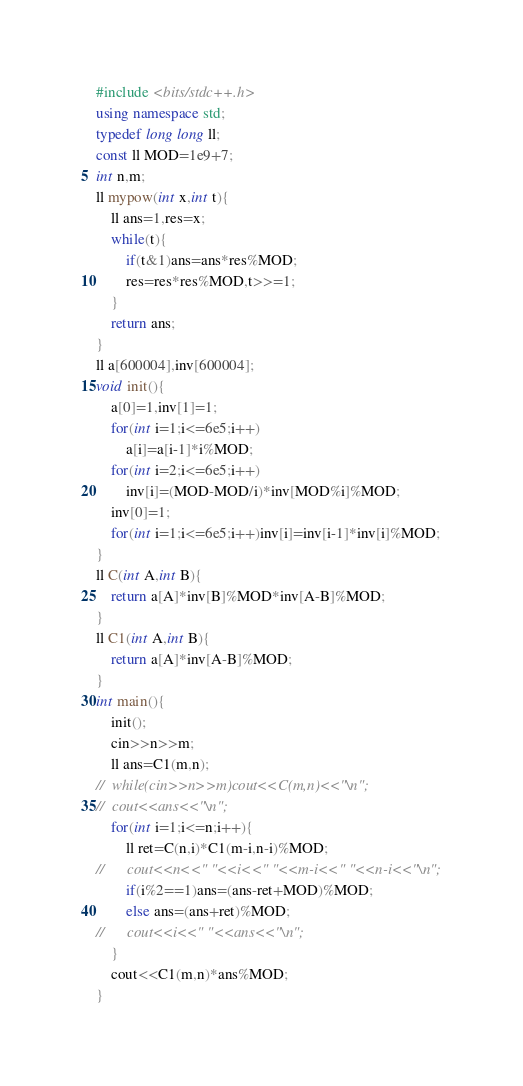Convert code to text. <code><loc_0><loc_0><loc_500><loc_500><_C++_>#include <bits/stdc++.h>
using namespace std;
typedef long long ll;
const ll MOD=1e9+7;
int n,m;
ll mypow(int x,int t){
	ll ans=1,res=x;
	while(t){
		if(t&1)ans=ans*res%MOD;
		res=res*res%MOD,t>>=1;
	}
	return ans;
}
ll a[600004],inv[600004];
void init(){
	a[0]=1,inv[1]=1;
	for(int i=1;i<=6e5;i++)
		a[i]=a[i-1]*i%MOD;
	for(int i=2;i<=6e5;i++)
		inv[i]=(MOD-MOD/i)*inv[MOD%i]%MOD;
	inv[0]=1;
	for(int i=1;i<=6e5;i++)inv[i]=inv[i-1]*inv[i]%MOD;
}
ll C(int A,int B){
	return a[A]*inv[B]%MOD*inv[A-B]%MOD;
}
ll C1(int A,int B){
	return a[A]*inv[A-B]%MOD;
}
int main(){
	init();
	cin>>n>>m;
	ll ans=C1(m,n);
//	while(cin>>n>>m)cout<<C(m,n)<<"\n"; 
//	cout<<ans<<"\n";
	for(int i=1;i<=n;i++){
		ll ret=C(n,i)*C1(m-i,n-i)%MOD;
//		cout<<n<<" "<<i<<" "<<m-i<<" "<<n-i<<"\n";
		if(i%2==1)ans=(ans-ret+MOD)%MOD;
		else ans=(ans+ret)%MOD;
//		cout<<i<<" "<<ans<<"\n";
	}
	cout<<C1(m,n)*ans%MOD;
}</code> 